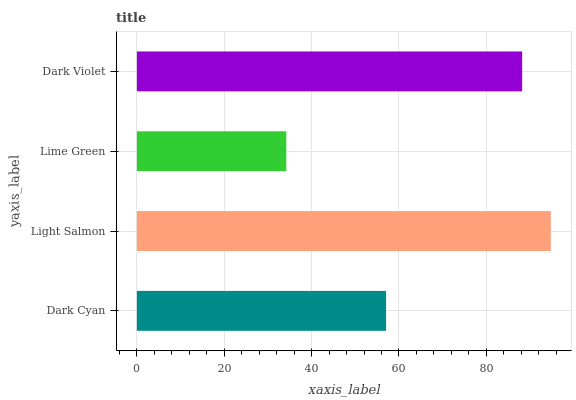Is Lime Green the minimum?
Answer yes or no. Yes. Is Light Salmon the maximum?
Answer yes or no. Yes. Is Light Salmon the minimum?
Answer yes or no. No. Is Lime Green the maximum?
Answer yes or no. No. Is Light Salmon greater than Lime Green?
Answer yes or no. Yes. Is Lime Green less than Light Salmon?
Answer yes or no. Yes. Is Lime Green greater than Light Salmon?
Answer yes or no. No. Is Light Salmon less than Lime Green?
Answer yes or no. No. Is Dark Violet the high median?
Answer yes or no. Yes. Is Dark Cyan the low median?
Answer yes or no. Yes. Is Dark Cyan the high median?
Answer yes or no. No. Is Light Salmon the low median?
Answer yes or no. No. 